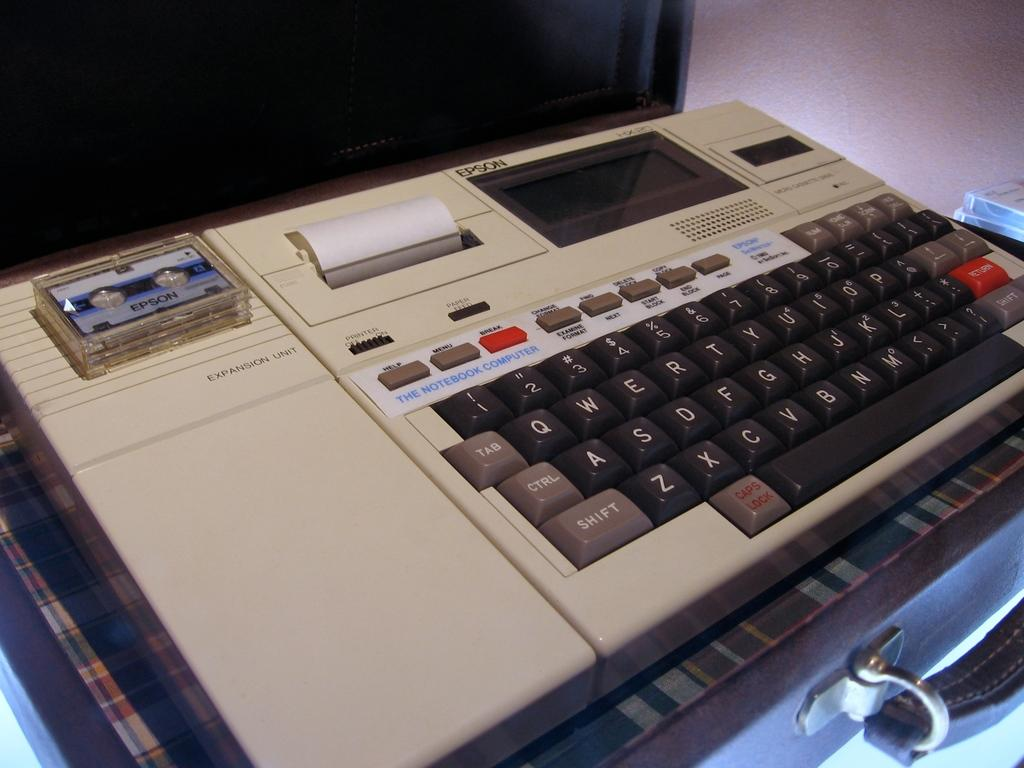<image>
Provide a brief description of the given image. An old tape recorder has a mini-tape in it that says Epson. 